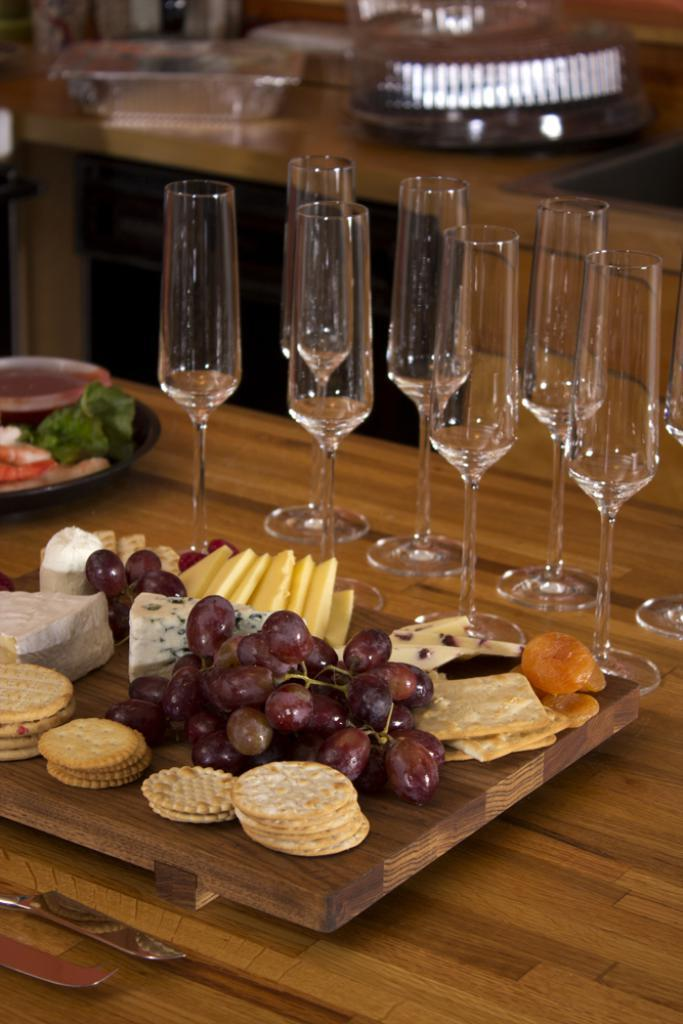What type of food items can be seen in the image? There are fruits and biscuits in the image. What type of tableware is present in the image? There are glasses in the image. What is the primary surface on which the food items and tableware are placed? All of these objects are on a table. What might be used for serving food in the image? There is a plate in the image for serving food. Where is the lunchroom located in the image? There is no lunchroom present in the image. Can you see any bees interacting with the food items in the image? There are no bees present in the image. Are there any dinosaurs visible in the image? There are no dinosaurs present in the image. 